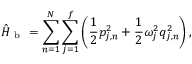<formula> <loc_0><loc_0><loc_500><loc_500>\hat { H } _ { b } = \sum _ { n = 1 } ^ { N } \sum _ { j = 1 } ^ { f } \left ( \frac { 1 } { 2 } p _ { j , n } ^ { 2 } + \frac { 1 } { 2 } \omega _ { j } ^ { 2 } q _ { j , n } ^ { 2 } \right ) ,</formula> 